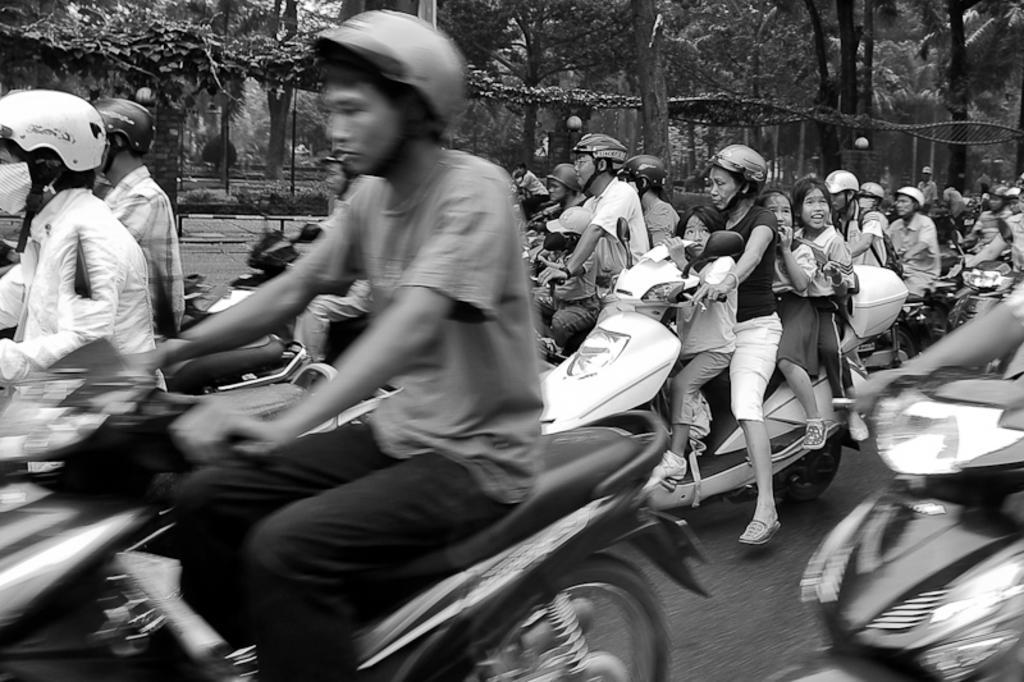Please provide a concise description of this image. A group of persons riding bikes and there are also some people sitting on there back and in front of them and there are trees beside them. 